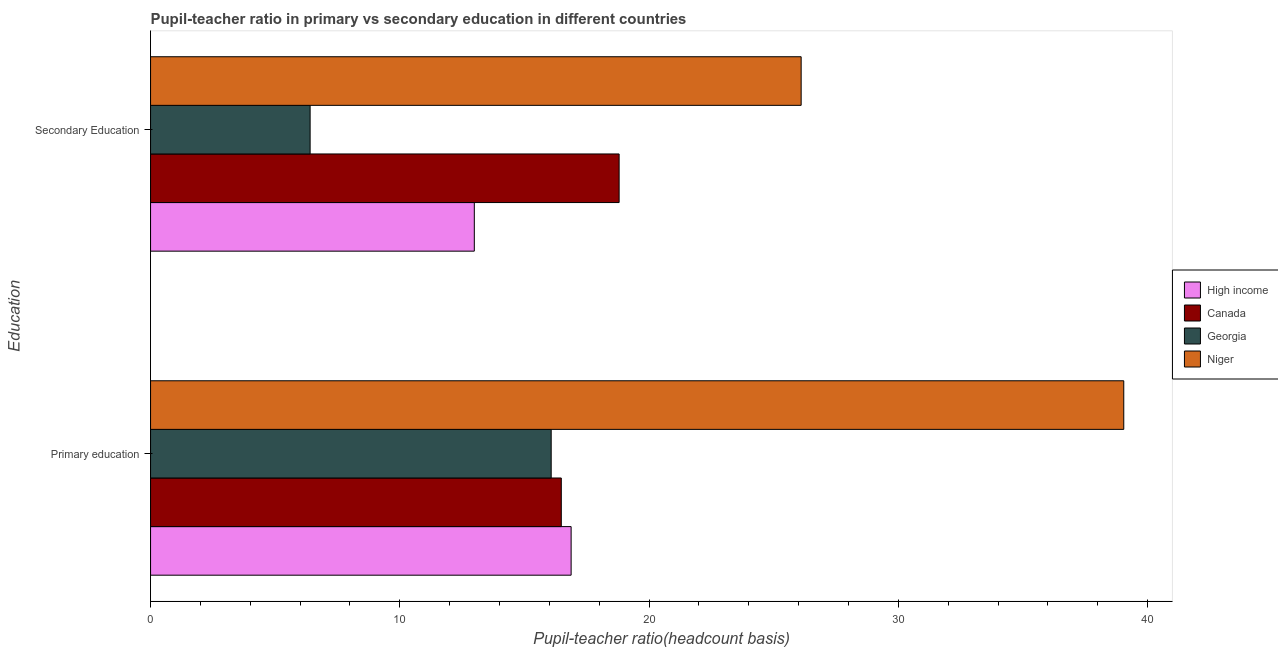How many different coloured bars are there?
Make the answer very short. 4. Are the number of bars per tick equal to the number of legend labels?
Provide a short and direct response. Yes. How many bars are there on the 1st tick from the bottom?
Make the answer very short. 4. What is the label of the 2nd group of bars from the top?
Ensure brevity in your answer.  Primary education. What is the pupil-teacher ratio in primary education in High income?
Provide a short and direct response. 16.87. Across all countries, what is the maximum pupil-teacher ratio in primary education?
Ensure brevity in your answer.  39.04. Across all countries, what is the minimum pupil-teacher ratio in primary education?
Ensure brevity in your answer.  16.07. In which country was the pupil teacher ratio on secondary education maximum?
Your answer should be very brief. Niger. In which country was the pupil-teacher ratio in primary education minimum?
Your answer should be very brief. Georgia. What is the total pupil teacher ratio on secondary education in the graph?
Provide a succinct answer. 64.29. What is the difference between the pupil teacher ratio on secondary education in Niger and that in Canada?
Keep it short and to the point. 7.3. What is the difference between the pupil teacher ratio on secondary education in Canada and the pupil-teacher ratio in primary education in High income?
Your answer should be very brief. 1.93. What is the average pupil-teacher ratio in primary education per country?
Provide a succinct answer. 22.12. What is the difference between the pupil teacher ratio on secondary education and pupil-teacher ratio in primary education in Canada?
Provide a succinct answer. 2.32. In how many countries, is the pupil-teacher ratio in primary education greater than 18 ?
Your response must be concise. 1. What is the ratio of the pupil-teacher ratio in primary education in Niger to that in Georgia?
Your response must be concise. 2.43. Is the pupil teacher ratio on secondary education in Georgia less than that in High income?
Your answer should be compact. Yes. In how many countries, is the pupil teacher ratio on secondary education greater than the average pupil teacher ratio on secondary education taken over all countries?
Offer a very short reply. 2. What does the 2nd bar from the top in Primary education represents?
Give a very brief answer. Georgia. Are all the bars in the graph horizontal?
Make the answer very short. Yes. What is the difference between two consecutive major ticks on the X-axis?
Make the answer very short. 10. Does the graph contain any zero values?
Ensure brevity in your answer.  No. Does the graph contain grids?
Make the answer very short. No. Where does the legend appear in the graph?
Provide a short and direct response. Center right. What is the title of the graph?
Ensure brevity in your answer.  Pupil-teacher ratio in primary vs secondary education in different countries. What is the label or title of the X-axis?
Your answer should be compact. Pupil-teacher ratio(headcount basis). What is the label or title of the Y-axis?
Keep it short and to the point. Education. What is the Pupil-teacher ratio(headcount basis) in High income in Primary education?
Provide a succinct answer. 16.87. What is the Pupil-teacher ratio(headcount basis) of Canada in Primary education?
Make the answer very short. 16.48. What is the Pupil-teacher ratio(headcount basis) in Georgia in Primary education?
Provide a short and direct response. 16.07. What is the Pupil-teacher ratio(headcount basis) of Niger in Primary education?
Offer a terse response. 39.04. What is the Pupil-teacher ratio(headcount basis) of High income in Secondary Education?
Your answer should be very brief. 12.99. What is the Pupil-teacher ratio(headcount basis) of Canada in Secondary Education?
Offer a terse response. 18.8. What is the Pupil-teacher ratio(headcount basis) of Georgia in Secondary Education?
Ensure brevity in your answer.  6.4. What is the Pupil-teacher ratio(headcount basis) in Niger in Secondary Education?
Provide a short and direct response. 26.1. Across all Education, what is the maximum Pupil-teacher ratio(headcount basis) of High income?
Your response must be concise. 16.87. Across all Education, what is the maximum Pupil-teacher ratio(headcount basis) of Canada?
Ensure brevity in your answer.  18.8. Across all Education, what is the maximum Pupil-teacher ratio(headcount basis) of Georgia?
Keep it short and to the point. 16.07. Across all Education, what is the maximum Pupil-teacher ratio(headcount basis) of Niger?
Provide a short and direct response. 39.04. Across all Education, what is the minimum Pupil-teacher ratio(headcount basis) in High income?
Your answer should be very brief. 12.99. Across all Education, what is the minimum Pupil-teacher ratio(headcount basis) of Canada?
Your response must be concise. 16.48. Across all Education, what is the minimum Pupil-teacher ratio(headcount basis) of Georgia?
Make the answer very short. 6.4. Across all Education, what is the minimum Pupil-teacher ratio(headcount basis) of Niger?
Give a very brief answer. 26.1. What is the total Pupil-teacher ratio(headcount basis) in High income in the graph?
Make the answer very short. 29.86. What is the total Pupil-teacher ratio(headcount basis) of Canada in the graph?
Ensure brevity in your answer.  35.28. What is the total Pupil-teacher ratio(headcount basis) in Georgia in the graph?
Provide a short and direct response. 22.47. What is the total Pupil-teacher ratio(headcount basis) of Niger in the graph?
Offer a very short reply. 65.15. What is the difference between the Pupil-teacher ratio(headcount basis) in High income in Primary education and that in Secondary Education?
Ensure brevity in your answer.  3.88. What is the difference between the Pupil-teacher ratio(headcount basis) of Canada in Primary education and that in Secondary Education?
Your answer should be very brief. -2.32. What is the difference between the Pupil-teacher ratio(headcount basis) in Georgia in Primary education and that in Secondary Education?
Your answer should be very brief. 9.67. What is the difference between the Pupil-teacher ratio(headcount basis) of Niger in Primary education and that in Secondary Education?
Give a very brief answer. 12.94. What is the difference between the Pupil-teacher ratio(headcount basis) in High income in Primary education and the Pupil-teacher ratio(headcount basis) in Canada in Secondary Education?
Make the answer very short. -1.93. What is the difference between the Pupil-teacher ratio(headcount basis) in High income in Primary education and the Pupil-teacher ratio(headcount basis) in Georgia in Secondary Education?
Ensure brevity in your answer.  10.47. What is the difference between the Pupil-teacher ratio(headcount basis) of High income in Primary education and the Pupil-teacher ratio(headcount basis) of Niger in Secondary Education?
Make the answer very short. -9.23. What is the difference between the Pupil-teacher ratio(headcount basis) in Canada in Primary education and the Pupil-teacher ratio(headcount basis) in Georgia in Secondary Education?
Offer a very short reply. 10.08. What is the difference between the Pupil-teacher ratio(headcount basis) in Canada in Primary education and the Pupil-teacher ratio(headcount basis) in Niger in Secondary Education?
Provide a short and direct response. -9.62. What is the difference between the Pupil-teacher ratio(headcount basis) in Georgia in Primary education and the Pupil-teacher ratio(headcount basis) in Niger in Secondary Education?
Ensure brevity in your answer.  -10.03. What is the average Pupil-teacher ratio(headcount basis) of High income per Education?
Provide a short and direct response. 14.93. What is the average Pupil-teacher ratio(headcount basis) in Canada per Education?
Keep it short and to the point. 17.64. What is the average Pupil-teacher ratio(headcount basis) of Georgia per Education?
Your answer should be very brief. 11.24. What is the average Pupil-teacher ratio(headcount basis) in Niger per Education?
Make the answer very short. 32.57. What is the difference between the Pupil-teacher ratio(headcount basis) in High income and Pupil-teacher ratio(headcount basis) in Canada in Primary education?
Provide a short and direct response. 0.39. What is the difference between the Pupil-teacher ratio(headcount basis) of High income and Pupil-teacher ratio(headcount basis) of Niger in Primary education?
Give a very brief answer. -22.17. What is the difference between the Pupil-teacher ratio(headcount basis) of Canada and Pupil-teacher ratio(headcount basis) of Georgia in Primary education?
Offer a very short reply. 0.41. What is the difference between the Pupil-teacher ratio(headcount basis) in Canada and Pupil-teacher ratio(headcount basis) in Niger in Primary education?
Keep it short and to the point. -22.57. What is the difference between the Pupil-teacher ratio(headcount basis) in Georgia and Pupil-teacher ratio(headcount basis) in Niger in Primary education?
Your answer should be compact. -22.97. What is the difference between the Pupil-teacher ratio(headcount basis) in High income and Pupil-teacher ratio(headcount basis) in Canada in Secondary Education?
Your answer should be very brief. -5.81. What is the difference between the Pupil-teacher ratio(headcount basis) of High income and Pupil-teacher ratio(headcount basis) of Georgia in Secondary Education?
Ensure brevity in your answer.  6.59. What is the difference between the Pupil-teacher ratio(headcount basis) of High income and Pupil-teacher ratio(headcount basis) of Niger in Secondary Education?
Your answer should be very brief. -13.11. What is the difference between the Pupil-teacher ratio(headcount basis) in Canada and Pupil-teacher ratio(headcount basis) in Georgia in Secondary Education?
Give a very brief answer. 12.4. What is the difference between the Pupil-teacher ratio(headcount basis) of Canada and Pupil-teacher ratio(headcount basis) of Niger in Secondary Education?
Keep it short and to the point. -7.3. What is the difference between the Pupil-teacher ratio(headcount basis) of Georgia and Pupil-teacher ratio(headcount basis) of Niger in Secondary Education?
Offer a terse response. -19.7. What is the ratio of the Pupil-teacher ratio(headcount basis) of High income in Primary education to that in Secondary Education?
Ensure brevity in your answer.  1.3. What is the ratio of the Pupil-teacher ratio(headcount basis) in Canada in Primary education to that in Secondary Education?
Make the answer very short. 0.88. What is the ratio of the Pupil-teacher ratio(headcount basis) in Georgia in Primary education to that in Secondary Education?
Your answer should be very brief. 2.51. What is the ratio of the Pupil-teacher ratio(headcount basis) in Niger in Primary education to that in Secondary Education?
Your response must be concise. 1.5. What is the difference between the highest and the second highest Pupil-teacher ratio(headcount basis) in High income?
Ensure brevity in your answer.  3.88. What is the difference between the highest and the second highest Pupil-teacher ratio(headcount basis) of Canada?
Provide a short and direct response. 2.32. What is the difference between the highest and the second highest Pupil-teacher ratio(headcount basis) of Georgia?
Your answer should be compact. 9.67. What is the difference between the highest and the second highest Pupil-teacher ratio(headcount basis) of Niger?
Your response must be concise. 12.94. What is the difference between the highest and the lowest Pupil-teacher ratio(headcount basis) of High income?
Offer a very short reply. 3.88. What is the difference between the highest and the lowest Pupil-teacher ratio(headcount basis) in Canada?
Make the answer very short. 2.32. What is the difference between the highest and the lowest Pupil-teacher ratio(headcount basis) in Georgia?
Give a very brief answer. 9.67. What is the difference between the highest and the lowest Pupil-teacher ratio(headcount basis) of Niger?
Your answer should be very brief. 12.94. 